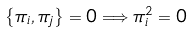<formula> <loc_0><loc_0><loc_500><loc_500>\left \{ \pi _ { i } , \pi _ { j } \right \} = 0 \Longrightarrow \pi _ { i } ^ { 2 } = 0</formula> 